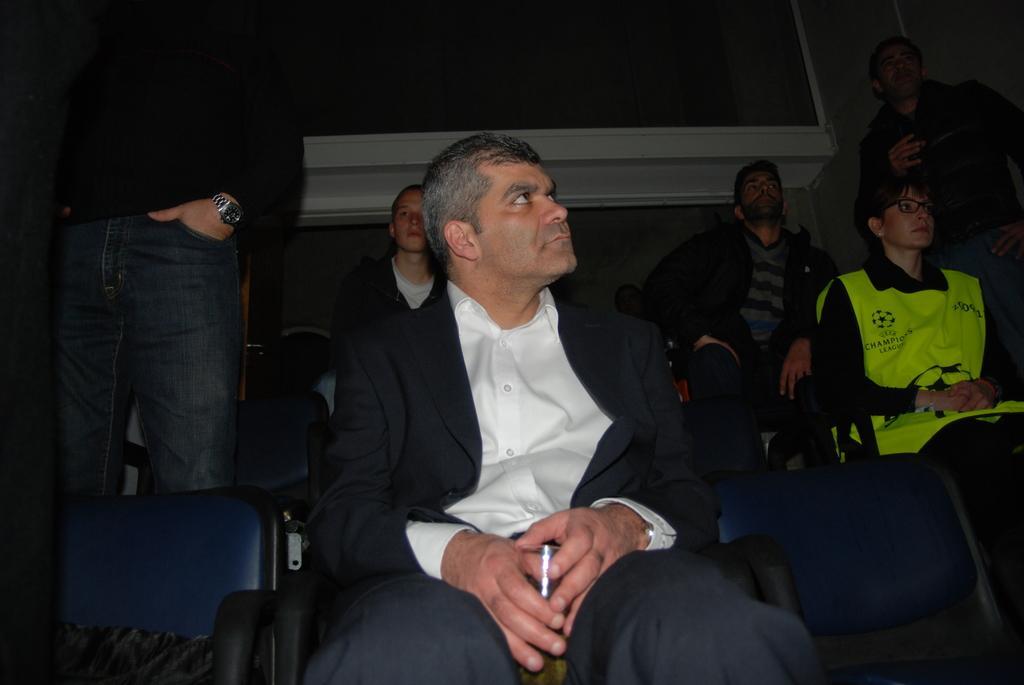Describe this image in one or two sentences. The picture consists of people sitting in chairs. On the right there is a person standing. On the left there is a person standing. At the top there is a window like object. 